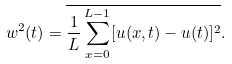Convert formula to latex. <formula><loc_0><loc_0><loc_500><loc_500>w ^ { 2 } ( t ) = \overline { \frac { 1 } { L } \sum _ { x = 0 } ^ { L - 1 } [ u ( x , t ) - u ( t ) ] ^ { 2 } } .</formula> 